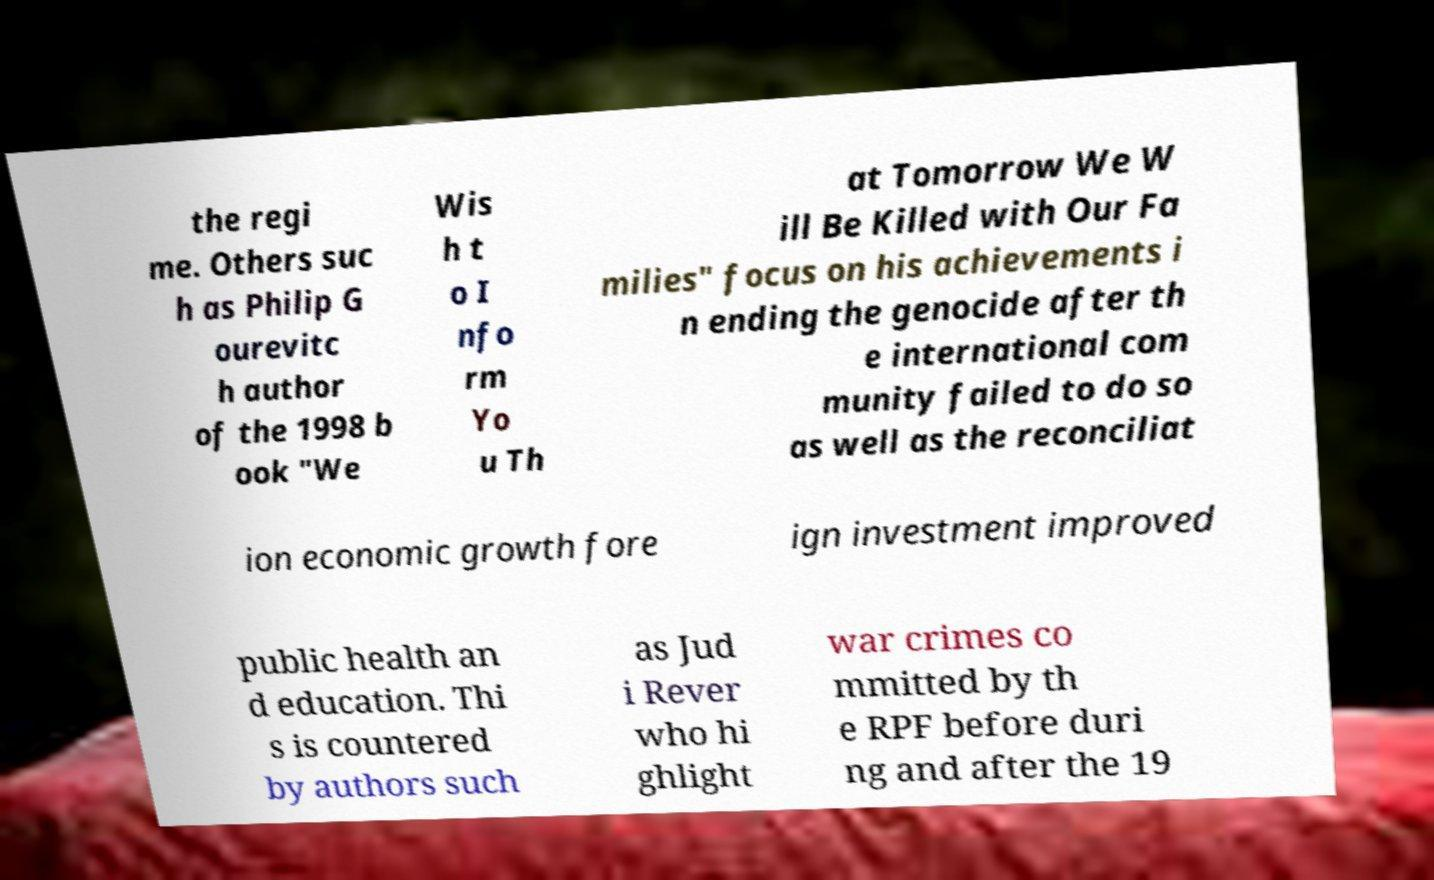There's text embedded in this image that I need extracted. Can you transcribe it verbatim? the regi me. Others suc h as Philip G ourevitc h author of the 1998 b ook "We Wis h t o I nfo rm Yo u Th at Tomorrow We W ill Be Killed with Our Fa milies" focus on his achievements i n ending the genocide after th e international com munity failed to do so as well as the reconciliat ion economic growth fore ign investment improved public health an d education. Thi s is countered by authors such as Jud i Rever who hi ghlight war crimes co mmitted by th e RPF before duri ng and after the 19 